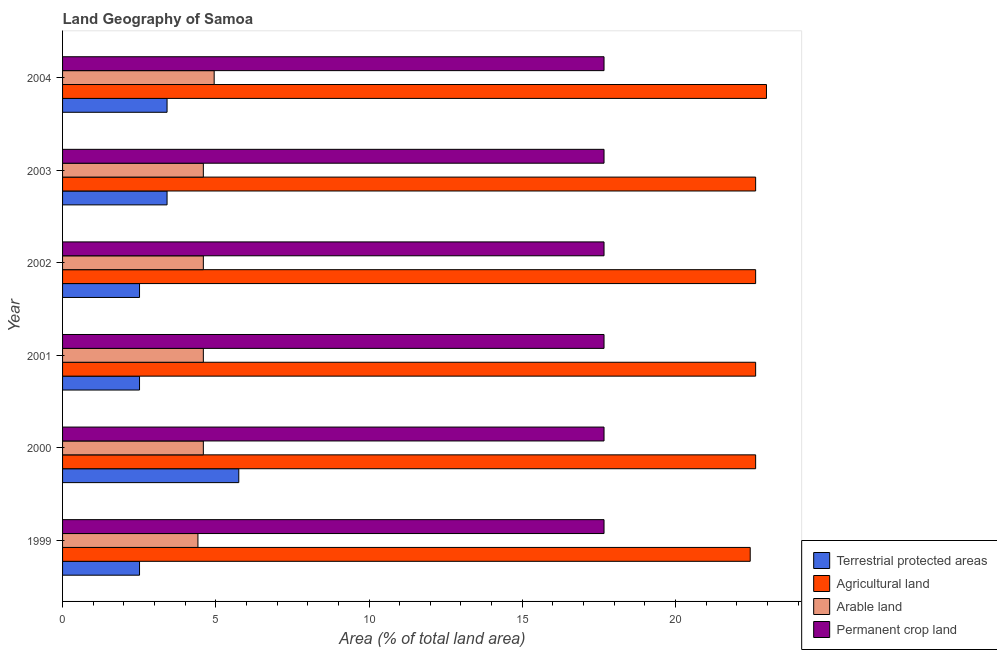Are the number of bars on each tick of the Y-axis equal?
Provide a succinct answer. Yes. What is the percentage of area under arable land in 2000?
Ensure brevity in your answer.  4.59. Across all years, what is the maximum percentage of land under terrestrial protection?
Your response must be concise. 5.75. Across all years, what is the minimum percentage of land under terrestrial protection?
Your answer should be very brief. 2.51. In which year was the percentage of area under permanent crop land minimum?
Give a very brief answer. 1999. What is the total percentage of area under agricultural land in the graph?
Ensure brevity in your answer.  135.87. What is the difference between the percentage of land under terrestrial protection in 1999 and that in 2001?
Provide a short and direct response. 0. What is the difference between the percentage of land under terrestrial protection in 2004 and the percentage of area under permanent crop land in 1999?
Your answer should be compact. -14.26. What is the average percentage of area under permanent crop land per year?
Make the answer very short. 17.67. In the year 2002, what is the difference between the percentage of area under agricultural land and percentage of area under arable land?
Provide a succinct answer. 18.02. What is the ratio of the percentage of land under terrestrial protection in 2003 to that in 2004?
Provide a short and direct response. 1. Is the percentage of area under arable land in 1999 less than that in 2002?
Provide a short and direct response. Yes. What is the difference between the highest and the lowest percentage of area under agricultural land?
Your response must be concise. 0.53. In how many years, is the percentage of area under arable land greater than the average percentage of area under arable land taken over all years?
Offer a terse response. 1. What does the 4th bar from the top in 1999 represents?
Provide a succinct answer. Terrestrial protected areas. What does the 3rd bar from the bottom in 2004 represents?
Your answer should be compact. Arable land. Are all the bars in the graph horizontal?
Keep it short and to the point. Yes. How many years are there in the graph?
Offer a very short reply. 6. Does the graph contain grids?
Provide a short and direct response. No. What is the title of the graph?
Your answer should be compact. Land Geography of Samoa. What is the label or title of the X-axis?
Make the answer very short. Area (% of total land area). What is the label or title of the Y-axis?
Offer a terse response. Year. What is the Area (% of total land area) of Terrestrial protected areas in 1999?
Give a very brief answer. 2.51. What is the Area (% of total land area) of Agricultural land in 1999?
Offer a very short reply. 22.44. What is the Area (% of total land area) in Arable land in 1999?
Your answer should be compact. 4.42. What is the Area (% of total land area) of Permanent crop land in 1999?
Make the answer very short. 17.67. What is the Area (% of total land area) of Terrestrial protected areas in 2000?
Offer a terse response. 5.75. What is the Area (% of total land area) of Agricultural land in 2000?
Offer a terse response. 22.61. What is the Area (% of total land area) in Arable land in 2000?
Provide a succinct answer. 4.59. What is the Area (% of total land area) in Permanent crop land in 2000?
Your answer should be compact. 17.67. What is the Area (% of total land area) in Terrestrial protected areas in 2001?
Provide a short and direct response. 2.51. What is the Area (% of total land area) in Agricultural land in 2001?
Provide a short and direct response. 22.61. What is the Area (% of total land area) in Arable land in 2001?
Give a very brief answer. 4.59. What is the Area (% of total land area) in Permanent crop land in 2001?
Offer a terse response. 17.67. What is the Area (% of total land area) of Terrestrial protected areas in 2002?
Give a very brief answer. 2.51. What is the Area (% of total land area) of Agricultural land in 2002?
Your answer should be very brief. 22.61. What is the Area (% of total land area) in Arable land in 2002?
Your answer should be compact. 4.59. What is the Area (% of total land area) in Permanent crop land in 2002?
Your answer should be very brief. 17.67. What is the Area (% of total land area) in Terrestrial protected areas in 2003?
Ensure brevity in your answer.  3.41. What is the Area (% of total land area) in Agricultural land in 2003?
Your response must be concise. 22.61. What is the Area (% of total land area) in Arable land in 2003?
Provide a succinct answer. 4.59. What is the Area (% of total land area) in Permanent crop land in 2003?
Keep it short and to the point. 17.67. What is the Area (% of total land area) of Terrestrial protected areas in 2004?
Keep it short and to the point. 3.41. What is the Area (% of total land area) of Agricultural land in 2004?
Ensure brevity in your answer.  22.97. What is the Area (% of total land area) of Arable land in 2004?
Ensure brevity in your answer.  4.95. What is the Area (% of total land area) in Permanent crop land in 2004?
Make the answer very short. 17.67. Across all years, what is the maximum Area (% of total land area) of Terrestrial protected areas?
Ensure brevity in your answer.  5.75. Across all years, what is the maximum Area (% of total land area) in Agricultural land?
Your answer should be very brief. 22.97. Across all years, what is the maximum Area (% of total land area) in Arable land?
Keep it short and to the point. 4.95. Across all years, what is the maximum Area (% of total land area) of Permanent crop land?
Give a very brief answer. 17.67. Across all years, what is the minimum Area (% of total land area) of Terrestrial protected areas?
Offer a terse response. 2.51. Across all years, what is the minimum Area (% of total land area) of Agricultural land?
Offer a very short reply. 22.44. Across all years, what is the minimum Area (% of total land area) in Arable land?
Give a very brief answer. 4.42. Across all years, what is the minimum Area (% of total land area) in Permanent crop land?
Offer a terse response. 17.67. What is the total Area (% of total land area) of Terrestrial protected areas in the graph?
Keep it short and to the point. 20.1. What is the total Area (% of total land area) of Agricultural land in the graph?
Provide a short and direct response. 135.87. What is the total Area (% of total land area) of Arable land in the graph?
Provide a succinct answer. 27.74. What is the total Area (% of total land area) in Permanent crop land in the graph?
Ensure brevity in your answer.  106.01. What is the difference between the Area (% of total land area) in Terrestrial protected areas in 1999 and that in 2000?
Your answer should be very brief. -3.24. What is the difference between the Area (% of total land area) of Agricultural land in 1999 and that in 2000?
Keep it short and to the point. -0.18. What is the difference between the Area (% of total land area) in Arable land in 1999 and that in 2000?
Your response must be concise. -0.18. What is the difference between the Area (% of total land area) in Agricultural land in 1999 and that in 2001?
Provide a short and direct response. -0.18. What is the difference between the Area (% of total land area) of Arable land in 1999 and that in 2001?
Your answer should be very brief. -0.18. What is the difference between the Area (% of total land area) of Permanent crop land in 1999 and that in 2001?
Provide a succinct answer. 0. What is the difference between the Area (% of total land area) of Agricultural land in 1999 and that in 2002?
Give a very brief answer. -0.18. What is the difference between the Area (% of total land area) of Arable land in 1999 and that in 2002?
Your answer should be very brief. -0.18. What is the difference between the Area (% of total land area) in Permanent crop land in 1999 and that in 2002?
Keep it short and to the point. 0. What is the difference between the Area (% of total land area) of Terrestrial protected areas in 1999 and that in 2003?
Ensure brevity in your answer.  -0.9. What is the difference between the Area (% of total land area) in Agricultural land in 1999 and that in 2003?
Offer a very short reply. -0.18. What is the difference between the Area (% of total land area) of Arable land in 1999 and that in 2003?
Offer a very short reply. -0.18. What is the difference between the Area (% of total land area) in Permanent crop land in 1999 and that in 2003?
Your answer should be compact. 0. What is the difference between the Area (% of total land area) of Terrestrial protected areas in 1999 and that in 2004?
Provide a succinct answer. -0.9. What is the difference between the Area (% of total land area) of Agricultural land in 1999 and that in 2004?
Your answer should be very brief. -0.53. What is the difference between the Area (% of total land area) in Arable land in 1999 and that in 2004?
Your response must be concise. -0.53. What is the difference between the Area (% of total land area) of Permanent crop land in 1999 and that in 2004?
Your response must be concise. 0. What is the difference between the Area (% of total land area) in Terrestrial protected areas in 2000 and that in 2001?
Provide a short and direct response. 3.24. What is the difference between the Area (% of total land area) in Agricultural land in 2000 and that in 2001?
Provide a succinct answer. 0. What is the difference between the Area (% of total land area) in Arable land in 2000 and that in 2001?
Offer a terse response. 0. What is the difference between the Area (% of total land area) in Permanent crop land in 2000 and that in 2001?
Offer a very short reply. 0. What is the difference between the Area (% of total land area) in Terrestrial protected areas in 2000 and that in 2002?
Keep it short and to the point. 3.24. What is the difference between the Area (% of total land area) in Arable land in 2000 and that in 2002?
Offer a terse response. 0. What is the difference between the Area (% of total land area) in Terrestrial protected areas in 2000 and that in 2003?
Your response must be concise. 2.34. What is the difference between the Area (% of total land area) in Agricultural land in 2000 and that in 2003?
Keep it short and to the point. 0. What is the difference between the Area (% of total land area) in Permanent crop land in 2000 and that in 2003?
Your answer should be very brief. 0. What is the difference between the Area (% of total land area) of Terrestrial protected areas in 2000 and that in 2004?
Your answer should be compact. 2.34. What is the difference between the Area (% of total land area) of Agricultural land in 2000 and that in 2004?
Keep it short and to the point. -0.35. What is the difference between the Area (% of total land area) of Arable land in 2000 and that in 2004?
Your response must be concise. -0.35. What is the difference between the Area (% of total land area) in Terrestrial protected areas in 2001 and that in 2002?
Provide a succinct answer. 0. What is the difference between the Area (% of total land area) of Agricultural land in 2001 and that in 2002?
Ensure brevity in your answer.  0. What is the difference between the Area (% of total land area) of Permanent crop land in 2001 and that in 2002?
Provide a short and direct response. 0. What is the difference between the Area (% of total land area) in Terrestrial protected areas in 2001 and that in 2003?
Offer a terse response. -0.9. What is the difference between the Area (% of total land area) of Agricultural land in 2001 and that in 2003?
Your answer should be very brief. 0. What is the difference between the Area (% of total land area) of Permanent crop land in 2001 and that in 2003?
Your answer should be very brief. 0. What is the difference between the Area (% of total land area) of Terrestrial protected areas in 2001 and that in 2004?
Your response must be concise. -0.9. What is the difference between the Area (% of total land area) of Agricultural land in 2001 and that in 2004?
Offer a very short reply. -0.35. What is the difference between the Area (% of total land area) of Arable land in 2001 and that in 2004?
Provide a short and direct response. -0.35. What is the difference between the Area (% of total land area) in Terrestrial protected areas in 2002 and that in 2003?
Offer a very short reply. -0.9. What is the difference between the Area (% of total land area) in Agricultural land in 2002 and that in 2003?
Keep it short and to the point. 0. What is the difference between the Area (% of total land area) in Permanent crop land in 2002 and that in 2003?
Offer a terse response. 0. What is the difference between the Area (% of total land area) of Terrestrial protected areas in 2002 and that in 2004?
Your answer should be very brief. -0.9. What is the difference between the Area (% of total land area) in Agricultural land in 2002 and that in 2004?
Offer a terse response. -0.35. What is the difference between the Area (% of total land area) of Arable land in 2002 and that in 2004?
Keep it short and to the point. -0.35. What is the difference between the Area (% of total land area) of Agricultural land in 2003 and that in 2004?
Your response must be concise. -0.35. What is the difference between the Area (% of total land area) in Arable land in 2003 and that in 2004?
Offer a terse response. -0.35. What is the difference between the Area (% of total land area) of Terrestrial protected areas in 1999 and the Area (% of total land area) of Agricultural land in 2000?
Make the answer very short. -20.1. What is the difference between the Area (% of total land area) in Terrestrial protected areas in 1999 and the Area (% of total land area) in Arable land in 2000?
Your answer should be very brief. -2.08. What is the difference between the Area (% of total land area) in Terrestrial protected areas in 1999 and the Area (% of total land area) in Permanent crop land in 2000?
Offer a terse response. -15.16. What is the difference between the Area (% of total land area) in Agricultural land in 1999 and the Area (% of total land area) in Arable land in 2000?
Your answer should be very brief. 17.84. What is the difference between the Area (% of total land area) in Agricultural land in 1999 and the Area (% of total land area) in Permanent crop land in 2000?
Keep it short and to the point. 4.77. What is the difference between the Area (% of total land area) in Arable land in 1999 and the Area (% of total land area) in Permanent crop land in 2000?
Keep it short and to the point. -13.25. What is the difference between the Area (% of total land area) in Terrestrial protected areas in 1999 and the Area (% of total land area) in Agricultural land in 2001?
Your answer should be compact. -20.1. What is the difference between the Area (% of total land area) in Terrestrial protected areas in 1999 and the Area (% of total land area) in Arable land in 2001?
Provide a short and direct response. -2.08. What is the difference between the Area (% of total land area) of Terrestrial protected areas in 1999 and the Area (% of total land area) of Permanent crop land in 2001?
Offer a very short reply. -15.16. What is the difference between the Area (% of total land area) in Agricultural land in 1999 and the Area (% of total land area) in Arable land in 2001?
Give a very brief answer. 17.84. What is the difference between the Area (% of total land area) in Agricultural land in 1999 and the Area (% of total land area) in Permanent crop land in 2001?
Ensure brevity in your answer.  4.77. What is the difference between the Area (% of total land area) in Arable land in 1999 and the Area (% of total land area) in Permanent crop land in 2001?
Give a very brief answer. -13.25. What is the difference between the Area (% of total land area) in Terrestrial protected areas in 1999 and the Area (% of total land area) in Agricultural land in 2002?
Your answer should be compact. -20.1. What is the difference between the Area (% of total land area) of Terrestrial protected areas in 1999 and the Area (% of total land area) of Arable land in 2002?
Your answer should be compact. -2.08. What is the difference between the Area (% of total land area) in Terrestrial protected areas in 1999 and the Area (% of total land area) in Permanent crop land in 2002?
Make the answer very short. -15.16. What is the difference between the Area (% of total land area) of Agricultural land in 1999 and the Area (% of total land area) of Arable land in 2002?
Your answer should be compact. 17.84. What is the difference between the Area (% of total land area) in Agricultural land in 1999 and the Area (% of total land area) in Permanent crop land in 2002?
Offer a terse response. 4.77. What is the difference between the Area (% of total land area) in Arable land in 1999 and the Area (% of total land area) in Permanent crop land in 2002?
Make the answer very short. -13.25. What is the difference between the Area (% of total land area) in Terrestrial protected areas in 1999 and the Area (% of total land area) in Agricultural land in 2003?
Provide a succinct answer. -20.1. What is the difference between the Area (% of total land area) in Terrestrial protected areas in 1999 and the Area (% of total land area) in Arable land in 2003?
Your answer should be compact. -2.08. What is the difference between the Area (% of total land area) in Terrestrial protected areas in 1999 and the Area (% of total land area) in Permanent crop land in 2003?
Provide a succinct answer. -15.16. What is the difference between the Area (% of total land area) in Agricultural land in 1999 and the Area (% of total land area) in Arable land in 2003?
Ensure brevity in your answer.  17.84. What is the difference between the Area (% of total land area) of Agricultural land in 1999 and the Area (% of total land area) of Permanent crop land in 2003?
Provide a short and direct response. 4.77. What is the difference between the Area (% of total land area) in Arable land in 1999 and the Area (% of total land area) in Permanent crop land in 2003?
Ensure brevity in your answer.  -13.25. What is the difference between the Area (% of total land area) in Terrestrial protected areas in 1999 and the Area (% of total land area) in Agricultural land in 2004?
Give a very brief answer. -20.46. What is the difference between the Area (% of total land area) in Terrestrial protected areas in 1999 and the Area (% of total land area) in Arable land in 2004?
Offer a terse response. -2.44. What is the difference between the Area (% of total land area) in Terrestrial protected areas in 1999 and the Area (% of total land area) in Permanent crop land in 2004?
Your answer should be compact. -15.16. What is the difference between the Area (% of total land area) of Agricultural land in 1999 and the Area (% of total land area) of Arable land in 2004?
Provide a succinct answer. 17.49. What is the difference between the Area (% of total land area) of Agricultural land in 1999 and the Area (% of total land area) of Permanent crop land in 2004?
Offer a very short reply. 4.77. What is the difference between the Area (% of total land area) in Arable land in 1999 and the Area (% of total land area) in Permanent crop land in 2004?
Ensure brevity in your answer.  -13.25. What is the difference between the Area (% of total land area) in Terrestrial protected areas in 2000 and the Area (% of total land area) in Agricultural land in 2001?
Provide a short and direct response. -16.87. What is the difference between the Area (% of total land area) in Terrestrial protected areas in 2000 and the Area (% of total land area) in Arable land in 2001?
Your answer should be very brief. 1.16. What is the difference between the Area (% of total land area) of Terrestrial protected areas in 2000 and the Area (% of total land area) of Permanent crop land in 2001?
Make the answer very short. -11.92. What is the difference between the Area (% of total land area) of Agricultural land in 2000 and the Area (% of total land area) of Arable land in 2001?
Ensure brevity in your answer.  18.02. What is the difference between the Area (% of total land area) in Agricultural land in 2000 and the Area (% of total land area) in Permanent crop land in 2001?
Keep it short and to the point. 4.95. What is the difference between the Area (% of total land area) of Arable land in 2000 and the Area (% of total land area) of Permanent crop land in 2001?
Keep it short and to the point. -13.07. What is the difference between the Area (% of total land area) of Terrestrial protected areas in 2000 and the Area (% of total land area) of Agricultural land in 2002?
Keep it short and to the point. -16.87. What is the difference between the Area (% of total land area) in Terrestrial protected areas in 2000 and the Area (% of total land area) in Arable land in 2002?
Give a very brief answer. 1.16. What is the difference between the Area (% of total land area) of Terrestrial protected areas in 2000 and the Area (% of total land area) of Permanent crop land in 2002?
Provide a short and direct response. -11.92. What is the difference between the Area (% of total land area) of Agricultural land in 2000 and the Area (% of total land area) of Arable land in 2002?
Offer a very short reply. 18.02. What is the difference between the Area (% of total land area) in Agricultural land in 2000 and the Area (% of total land area) in Permanent crop land in 2002?
Your answer should be compact. 4.95. What is the difference between the Area (% of total land area) in Arable land in 2000 and the Area (% of total land area) in Permanent crop land in 2002?
Give a very brief answer. -13.07. What is the difference between the Area (% of total land area) in Terrestrial protected areas in 2000 and the Area (% of total land area) in Agricultural land in 2003?
Give a very brief answer. -16.87. What is the difference between the Area (% of total land area) of Terrestrial protected areas in 2000 and the Area (% of total land area) of Arable land in 2003?
Ensure brevity in your answer.  1.16. What is the difference between the Area (% of total land area) of Terrestrial protected areas in 2000 and the Area (% of total land area) of Permanent crop land in 2003?
Give a very brief answer. -11.92. What is the difference between the Area (% of total land area) of Agricultural land in 2000 and the Area (% of total land area) of Arable land in 2003?
Offer a terse response. 18.02. What is the difference between the Area (% of total land area) of Agricultural land in 2000 and the Area (% of total land area) of Permanent crop land in 2003?
Provide a succinct answer. 4.95. What is the difference between the Area (% of total land area) in Arable land in 2000 and the Area (% of total land area) in Permanent crop land in 2003?
Your answer should be very brief. -13.07. What is the difference between the Area (% of total land area) in Terrestrial protected areas in 2000 and the Area (% of total land area) in Agricultural land in 2004?
Keep it short and to the point. -17.22. What is the difference between the Area (% of total land area) of Terrestrial protected areas in 2000 and the Area (% of total land area) of Arable land in 2004?
Keep it short and to the point. 0.8. What is the difference between the Area (% of total land area) in Terrestrial protected areas in 2000 and the Area (% of total land area) in Permanent crop land in 2004?
Your response must be concise. -11.92. What is the difference between the Area (% of total land area) in Agricultural land in 2000 and the Area (% of total land area) in Arable land in 2004?
Provide a succinct answer. 17.67. What is the difference between the Area (% of total land area) of Agricultural land in 2000 and the Area (% of total land area) of Permanent crop land in 2004?
Your response must be concise. 4.95. What is the difference between the Area (% of total land area) of Arable land in 2000 and the Area (% of total land area) of Permanent crop land in 2004?
Your response must be concise. -13.07. What is the difference between the Area (% of total land area) of Terrestrial protected areas in 2001 and the Area (% of total land area) of Agricultural land in 2002?
Keep it short and to the point. -20.1. What is the difference between the Area (% of total land area) of Terrestrial protected areas in 2001 and the Area (% of total land area) of Arable land in 2002?
Your response must be concise. -2.08. What is the difference between the Area (% of total land area) in Terrestrial protected areas in 2001 and the Area (% of total land area) in Permanent crop land in 2002?
Ensure brevity in your answer.  -15.16. What is the difference between the Area (% of total land area) in Agricultural land in 2001 and the Area (% of total land area) in Arable land in 2002?
Offer a terse response. 18.02. What is the difference between the Area (% of total land area) of Agricultural land in 2001 and the Area (% of total land area) of Permanent crop land in 2002?
Give a very brief answer. 4.95. What is the difference between the Area (% of total land area) of Arable land in 2001 and the Area (% of total land area) of Permanent crop land in 2002?
Make the answer very short. -13.07. What is the difference between the Area (% of total land area) in Terrestrial protected areas in 2001 and the Area (% of total land area) in Agricultural land in 2003?
Offer a terse response. -20.1. What is the difference between the Area (% of total land area) of Terrestrial protected areas in 2001 and the Area (% of total land area) of Arable land in 2003?
Give a very brief answer. -2.08. What is the difference between the Area (% of total land area) in Terrestrial protected areas in 2001 and the Area (% of total land area) in Permanent crop land in 2003?
Offer a terse response. -15.16. What is the difference between the Area (% of total land area) in Agricultural land in 2001 and the Area (% of total land area) in Arable land in 2003?
Give a very brief answer. 18.02. What is the difference between the Area (% of total land area) in Agricultural land in 2001 and the Area (% of total land area) in Permanent crop land in 2003?
Provide a succinct answer. 4.95. What is the difference between the Area (% of total land area) of Arable land in 2001 and the Area (% of total land area) of Permanent crop land in 2003?
Keep it short and to the point. -13.07. What is the difference between the Area (% of total land area) in Terrestrial protected areas in 2001 and the Area (% of total land area) in Agricultural land in 2004?
Provide a short and direct response. -20.46. What is the difference between the Area (% of total land area) in Terrestrial protected areas in 2001 and the Area (% of total land area) in Arable land in 2004?
Provide a succinct answer. -2.44. What is the difference between the Area (% of total land area) of Terrestrial protected areas in 2001 and the Area (% of total land area) of Permanent crop land in 2004?
Ensure brevity in your answer.  -15.16. What is the difference between the Area (% of total land area) in Agricultural land in 2001 and the Area (% of total land area) in Arable land in 2004?
Your answer should be compact. 17.67. What is the difference between the Area (% of total land area) in Agricultural land in 2001 and the Area (% of total land area) in Permanent crop land in 2004?
Offer a terse response. 4.95. What is the difference between the Area (% of total land area) of Arable land in 2001 and the Area (% of total land area) of Permanent crop land in 2004?
Give a very brief answer. -13.07. What is the difference between the Area (% of total land area) of Terrestrial protected areas in 2002 and the Area (% of total land area) of Agricultural land in 2003?
Your answer should be very brief. -20.1. What is the difference between the Area (% of total land area) of Terrestrial protected areas in 2002 and the Area (% of total land area) of Arable land in 2003?
Offer a terse response. -2.08. What is the difference between the Area (% of total land area) in Terrestrial protected areas in 2002 and the Area (% of total land area) in Permanent crop land in 2003?
Provide a short and direct response. -15.16. What is the difference between the Area (% of total land area) of Agricultural land in 2002 and the Area (% of total land area) of Arable land in 2003?
Offer a terse response. 18.02. What is the difference between the Area (% of total land area) of Agricultural land in 2002 and the Area (% of total land area) of Permanent crop land in 2003?
Provide a short and direct response. 4.95. What is the difference between the Area (% of total land area) in Arable land in 2002 and the Area (% of total land area) in Permanent crop land in 2003?
Your answer should be compact. -13.07. What is the difference between the Area (% of total land area) of Terrestrial protected areas in 2002 and the Area (% of total land area) of Agricultural land in 2004?
Make the answer very short. -20.46. What is the difference between the Area (% of total land area) in Terrestrial protected areas in 2002 and the Area (% of total land area) in Arable land in 2004?
Your response must be concise. -2.44. What is the difference between the Area (% of total land area) in Terrestrial protected areas in 2002 and the Area (% of total land area) in Permanent crop land in 2004?
Your response must be concise. -15.16. What is the difference between the Area (% of total land area) in Agricultural land in 2002 and the Area (% of total land area) in Arable land in 2004?
Make the answer very short. 17.67. What is the difference between the Area (% of total land area) of Agricultural land in 2002 and the Area (% of total land area) of Permanent crop land in 2004?
Keep it short and to the point. 4.95. What is the difference between the Area (% of total land area) of Arable land in 2002 and the Area (% of total land area) of Permanent crop land in 2004?
Make the answer very short. -13.07. What is the difference between the Area (% of total land area) in Terrestrial protected areas in 2003 and the Area (% of total land area) in Agricultural land in 2004?
Offer a terse response. -19.56. What is the difference between the Area (% of total land area) of Terrestrial protected areas in 2003 and the Area (% of total land area) of Arable land in 2004?
Offer a very short reply. -1.54. What is the difference between the Area (% of total land area) in Terrestrial protected areas in 2003 and the Area (% of total land area) in Permanent crop land in 2004?
Provide a succinct answer. -14.26. What is the difference between the Area (% of total land area) in Agricultural land in 2003 and the Area (% of total land area) in Arable land in 2004?
Give a very brief answer. 17.67. What is the difference between the Area (% of total land area) of Agricultural land in 2003 and the Area (% of total land area) of Permanent crop land in 2004?
Your response must be concise. 4.95. What is the difference between the Area (% of total land area) in Arable land in 2003 and the Area (% of total land area) in Permanent crop land in 2004?
Provide a succinct answer. -13.07. What is the average Area (% of total land area) of Terrestrial protected areas per year?
Offer a very short reply. 3.35. What is the average Area (% of total land area) in Agricultural land per year?
Your response must be concise. 22.64. What is the average Area (% of total land area) in Arable land per year?
Offer a terse response. 4.62. What is the average Area (% of total land area) of Permanent crop land per year?
Provide a succinct answer. 17.67. In the year 1999, what is the difference between the Area (% of total land area) in Terrestrial protected areas and Area (% of total land area) in Agricultural land?
Ensure brevity in your answer.  -19.93. In the year 1999, what is the difference between the Area (% of total land area) of Terrestrial protected areas and Area (% of total land area) of Arable land?
Your answer should be compact. -1.91. In the year 1999, what is the difference between the Area (% of total land area) of Terrestrial protected areas and Area (% of total land area) of Permanent crop land?
Provide a succinct answer. -15.16. In the year 1999, what is the difference between the Area (% of total land area) of Agricultural land and Area (% of total land area) of Arable land?
Your answer should be very brief. 18.02. In the year 1999, what is the difference between the Area (% of total land area) of Agricultural land and Area (% of total land area) of Permanent crop land?
Your answer should be very brief. 4.77. In the year 1999, what is the difference between the Area (% of total land area) of Arable land and Area (% of total land area) of Permanent crop land?
Your answer should be very brief. -13.25. In the year 2000, what is the difference between the Area (% of total land area) in Terrestrial protected areas and Area (% of total land area) in Agricultural land?
Offer a terse response. -16.87. In the year 2000, what is the difference between the Area (% of total land area) in Terrestrial protected areas and Area (% of total land area) in Arable land?
Give a very brief answer. 1.16. In the year 2000, what is the difference between the Area (% of total land area) in Terrestrial protected areas and Area (% of total land area) in Permanent crop land?
Offer a terse response. -11.92. In the year 2000, what is the difference between the Area (% of total land area) of Agricultural land and Area (% of total land area) of Arable land?
Keep it short and to the point. 18.02. In the year 2000, what is the difference between the Area (% of total land area) of Agricultural land and Area (% of total land area) of Permanent crop land?
Keep it short and to the point. 4.95. In the year 2000, what is the difference between the Area (% of total land area) of Arable land and Area (% of total land area) of Permanent crop land?
Your answer should be very brief. -13.07. In the year 2001, what is the difference between the Area (% of total land area) of Terrestrial protected areas and Area (% of total land area) of Agricultural land?
Provide a succinct answer. -20.1. In the year 2001, what is the difference between the Area (% of total land area) in Terrestrial protected areas and Area (% of total land area) in Arable land?
Provide a succinct answer. -2.08. In the year 2001, what is the difference between the Area (% of total land area) in Terrestrial protected areas and Area (% of total land area) in Permanent crop land?
Keep it short and to the point. -15.16. In the year 2001, what is the difference between the Area (% of total land area) of Agricultural land and Area (% of total land area) of Arable land?
Keep it short and to the point. 18.02. In the year 2001, what is the difference between the Area (% of total land area) in Agricultural land and Area (% of total land area) in Permanent crop land?
Make the answer very short. 4.95. In the year 2001, what is the difference between the Area (% of total land area) in Arable land and Area (% of total land area) in Permanent crop land?
Give a very brief answer. -13.07. In the year 2002, what is the difference between the Area (% of total land area) in Terrestrial protected areas and Area (% of total land area) in Agricultural land?
Provide a short and direct response. -20.1. In the year 2002, what is the difference between the Area (% of total land area) of Terrestrial protected areas and Area (% of total land area) of Arable land?
Offer a terse response. -2.08. In the year 2002, what is the difference between the Area (% of total land area) of Terrestrial protected areas and Area (% of total land area) of Permanent crop land?
Your answer should be compact. -15.16. In the year 2002, what is the difference between the Area (% of total land area) of Agricultural land and Area (% of total land area) of Arable land?
Provide a succinct answer. 18.02. In the year 2002, what is the difference between the Area (% of total land area) in Agricultural land and Area (% of total land area) in Permanent crop land?
Offer a very short reply. 4.95. In the year 2002, what is the difference between the Area (% of total land area) of Arable land and Area (% of total land area) of Permanent crop land?
Offer a very short reply. -13.07. In the year 2003, what is the difference between the Area (% of total land area) of Terrestrial protected areas and Area (% of total land area) of Agricultural land?
Offer a very short reply. -19.21. In the year 2003, what is the difference between the Area (% of total land area) in Terrestrial protected areas and Area (% of total land area) in Arable land?
Your answer should be compact. -1.18. In the year 2003, what is the difference between the Area (% of total land area) in Terrestrial protected areas and Area (% of total land area) in Permanent crop land?
Ensure brevity in your answer.  -14.26. In the year 2003, what is the difference between the Area (% of total land area) of Agricultural land and Area (% of total land area) of Arable land?
Offer a very short reply. 18.02. In the year 2003, what is the difference between the Area (% of total land area) of Agricultural land and Area (% of total land area) of Permanent crop land?
Keep it short and to the point. 4.95. In the year 2003, what is the difference between the Area (% of total land area) in Arable land and Area (% of total land area) in Permanent crop land?
Provide a short and direct response. -13.07. In the year 2004, what is the difference between the Area (% of total land area) in Terrestrial protected areas and Area (% of total land area) in Agricultural land?
Your answer should be very brief. -19.56. In the year 2004, what is the difference between the Area (% of total land area) in Terrestrial protected areas and Area (% of total land area) in Arable land?
Your answer should be very brief. -1.54. In the year 2004, what is the difference between the Area (% of total land area) of Terrestrial protected areas and Area (% of total land area) of Permanent crop land?
Provide a succinct answer. -14.26. In the year 2004, what is the difference between the Area (% of total land area) of Agricultural land and Area (% of total land area) of Arable land?
Offer a very short reply. 18.02. In the year 2004, what is the difference between the Area (% of total land area) in Agricultural land and Area (% of total land area) in Permanent crop land?
Provide a short and direct response. 5.3. In the year 2004, what is the difference between the Area (% of total land area) in Arable land and Area (% of total land area) in Permanent crop land?
Provide a short and direct response. -12.72. What is the ratio of the Area (% of total land area) of Terrestrial protected areas in 1999 to that in 2000?
Keep it short and to the point. 0.44. What is the ratio of the Area (% of total land area) of Arable land in 1999 to that in 2000?
Provide a succinct answer. 0.96. What is the ratio of the Area (% of total land area) of Agricultural land in 1999 to that in 2001?
Provide a short and direct response. 0.99. What is the ratio of the Area (% of total land area) of Arable land in 1999 to that in 2001?
Give a very brief answer. 0.96. What is the ratio of the Area (% of total land area) in Agricultural land in 1999 to that in 2002?
Ensure brevity in your answer.  0.99. What is the ratio of the Area (% of total land area) in Arable land in 1999 to that in 2002?
Give a very brief answer. 0.96. What is the ratio of the Area (% of total land area) of Permanent crop land in 1999 to that in 2002?
Ensure brevity in your answer.  1. What is the ratio of the Area (% of total land area) in Terrestrial protected areas in 1999 to that in 2003?
Provide a succinct answer. 0.74. What is the ratio of the Area (% of total land area) of Arable land in 1999 to that in 2003?
Provide a succinct answer. 0.96. What is the ratio of the Area (% of total land area) in Permanent crop land in 1999 to that in 2003?
Offer a very short reply. 1. What is the ratio of the Area (% of total land area) of Terrestrial protected areas in 1999 to that in 2004?
Make the answer very short. 0.74. What is the ratio of the Area (% of total land area) of Agricultural land in 1999 to that in 2004?
Give a very brief answer. 0.98. What is the ratio of the Area (% of total land area) of Arable land in 1999 to that in 2004?
Make the answer very short. 0.89. What is the ratio of the Area (% of total land area) of Terrestrial protected areas in 2000 to that in 2001?
Offer a very short reply. 2.29. What is the ratio of the Area (% of total land area) of Arable land in 2000 to that in 2001?
Make the answer very short. 1. What is the ratio of the Area (% of total land area) in Terrestrial protected areas in 2000 to that in 2002?
Provide a succinct answer. 2.29. What is the ratio of the Area (% of total land area) of Permanent crop land in 2000 to that in 2002?
Your response must be concise. 1. What is the ratio of the Area (% of total land area) of Terrestrial protected areas in 2000 to that in 2003?
Keep it short and to the point. 1.69. What is the ratio of the Area (% of total land area) in Agricultural land in 2000 to that in 2003?
Your response must be concise. 1. What is the ratio of the Area (% of total land area) in Arable land in 2000 to that in 2003?
Provide a short and direct response. 1. What is the ratio of the Area (% of total land area) in Permanent crop land in 2000 to that in 2003?
Make the answer very short. 1. What is the ratio of the Area (% of total land area) in Terrestrial protected areas in 2000 to that in 2004?
Give a very brief answer. 1.69. What is the ratio of the Area (% of total land area) of Agricultural land in 2000 to that in 2004?
Your response must be concise. 0.98. What is the ratio of the Area (% of total land area) in Permanent crop land in 2000 to that in 2004?
Offer a terse response. 1. What is the ratio of the Area (% of total land area) in Terrestrial protected areas in 2001 to that in 2002?
Offer a terse response. 1. What is the ratio of the Area (% of total land area) of Agricultural land in 2001 to that in 2002?
Give a very brief answer. 1. What is the ratio of the Area (% of total land area) of Arable land in 2001 to that in 2002?
Offer a terse response. 1. What is the ratio of the Area (% of total land area) in Permanent crop land in 2001 to that in 2002?
Provide a short and direct response. 1. What is the ratio of the Area (% of total land area) in Terrestrial protected areas in 2001 to that in 2003?
Offer a terse response. 0.74. What is the ratio of the Area (% of total land area) of Arable land in 2001 to that in 2003?
Offer a very short reply. 1. What is the ratio of the Area (% of total land area) in Permanent crop land in 2001 to that in 2003?
Your answer should be very brief. 1. What is the ratio of the Area (% of total land area) of Terrestrial protected areas in 2001 to that in 2004?
Your response must be concise. 0.74. What is the ratio of the Area (% of total land area) in Agricultural land in 2001 to that in 2004?
Provide a short and direct response. 0.98. What is the ratio of the Area (% of total land area) in Arable land in 2001 to that in 2004?
Your response must be concise. 0.93. What is the ratio of the Area (% of total land area) of Terrestrial protected areas in 2002 to that in 2003?
Ensure brevity in your answer.  0.74. What is the ratio of the Area (% of total land area) of Permanent crop land in 2002 to that in 2003?
Offer a terse response. 1. What is the ratio of the Area (% of total land area) of Terrestrial protected areas in 2002 to that in 2004?
Ensure brevity in your answer.  0.74. What is the ratio of the Area (% of total land area) of Agricultural land in 2002 to that in 2004?
Provide a succinct answer. 0.98. What is the ratio of the Area (% of total land area) of Arable land in 2002 to that in 2004?
Keep it short and to the point. 0.93. What is the ratio of the Area (% of total land area) of Permanent crop land in 2002 to that in 2004?
Your response must be concise. 1. What is the ratio of the Area (% of total land area) of Terrestrial protected areas in 2003 to that in 2004?
Offer a very short reply. 1. What is the ratio of the Area (% of total land area) of Agricultural land in 2003 to that in 2004?
Provide a succinct answer. 0.98. What is the ratio of the Area (% of total land area) of Arable land in 2003 to that in 2004?
Offer a very short reply. 0.93. What is the difference between the highest and the second highest Area (% of total land area) of Terrestrial protected areas?
Keep it short and to the point. 2.34. What is the difference between the highest and the second highest Area (% of total land area) in Agricultural land?
Make the answer very short. 0.35. What is the difference between the highest and the second highest Area (% of total land area) of Arable land?
Provide a short and direct response. 0.35. What is the difference between the highest and the lowest Area (% of total land area) of Terrestrial protected areas?
Offer a terse response. 3.24. What is the difference between the highest and the lowest Area (% of total land area) of Agricultural land?
Your answer should be compact. 0.53. What is the difference between the highest and the lowest Area (% of total land area) in Arable land?
Your answer should be compact. 0.53. 